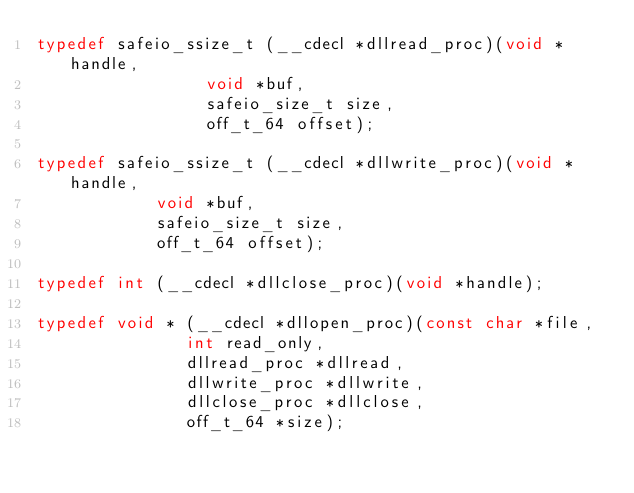<code> <loc_0><loc_0><loc_500><loc_500><_C_>typedef safeio_ssize_t (__cdecl *dllread_proc)(void *handle,
					       void *buf,
					       safeio_size_t size,
					       off_t_64 offset);

typedef safeio_ssize_t (__cdecl *dllwrite_proc)(void *handle,
						void *buf,
						safeio_size_t size,
						off_t_64 offset);

typedef int (__cdecl *dllclose_proc)(void *handle);

typedef void * (__cdecl *dllopen_proc)(const char *file,
				       int read_only,
				       dllread_proc *dllread,
				       dllwrite_proc *dllwrite,
				       dllclose_proc *dllclose,
				       off_t_64 *size);

</code> 